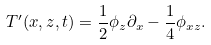<formula> <loc_0><loc_0><loc_500><loc_500>T ^ { \prime } ( x , z , t ) = \frac { 1 } { 2 } \phi _ { z } \partial _ { x } - \frac { 1 } { 4 } \phi _ { x z } .</formula> 